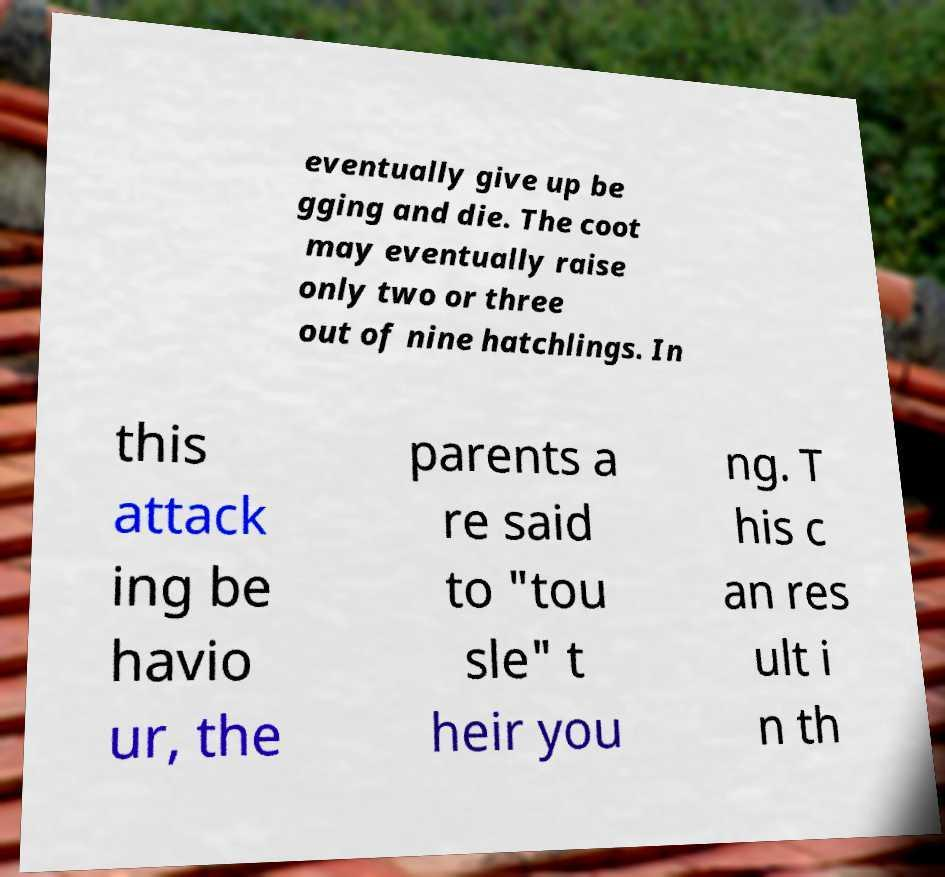Please identify and transcribe the text found in this image. eventually give up be gging and die. The coot may eventually raise only two or three out of nine hatchlings. In this attack ing be havio ur, the parents a re said to "tou sle" t heir you ng. T his c an res ult i n th 